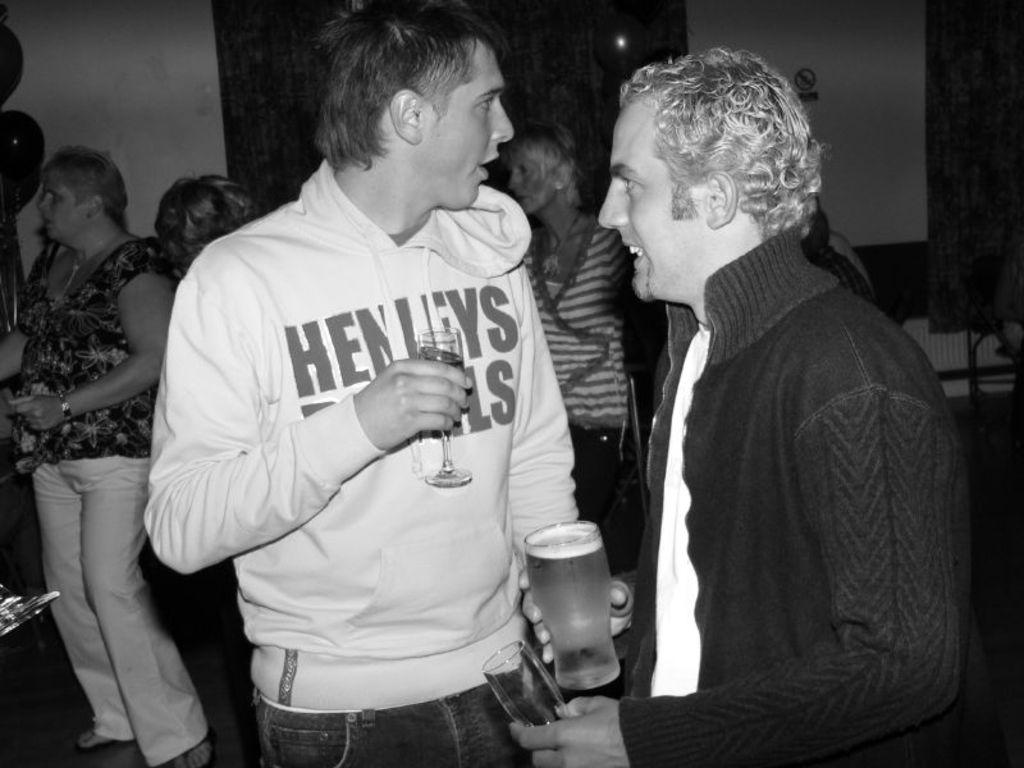How many people are in the center of the image? There are two people standing in the center of the image. What are the two people holding in their hands? The two people are holding glasses in their hands. Can you describe the background of the image? There are people in the background of the image, along with a wall and a curtain. What type of amusement can be seen at the seashore in the image? There is no amusement or seashore present in the image; it features two people holding glasses in the center and a background with people, a wall, and a curtain. 